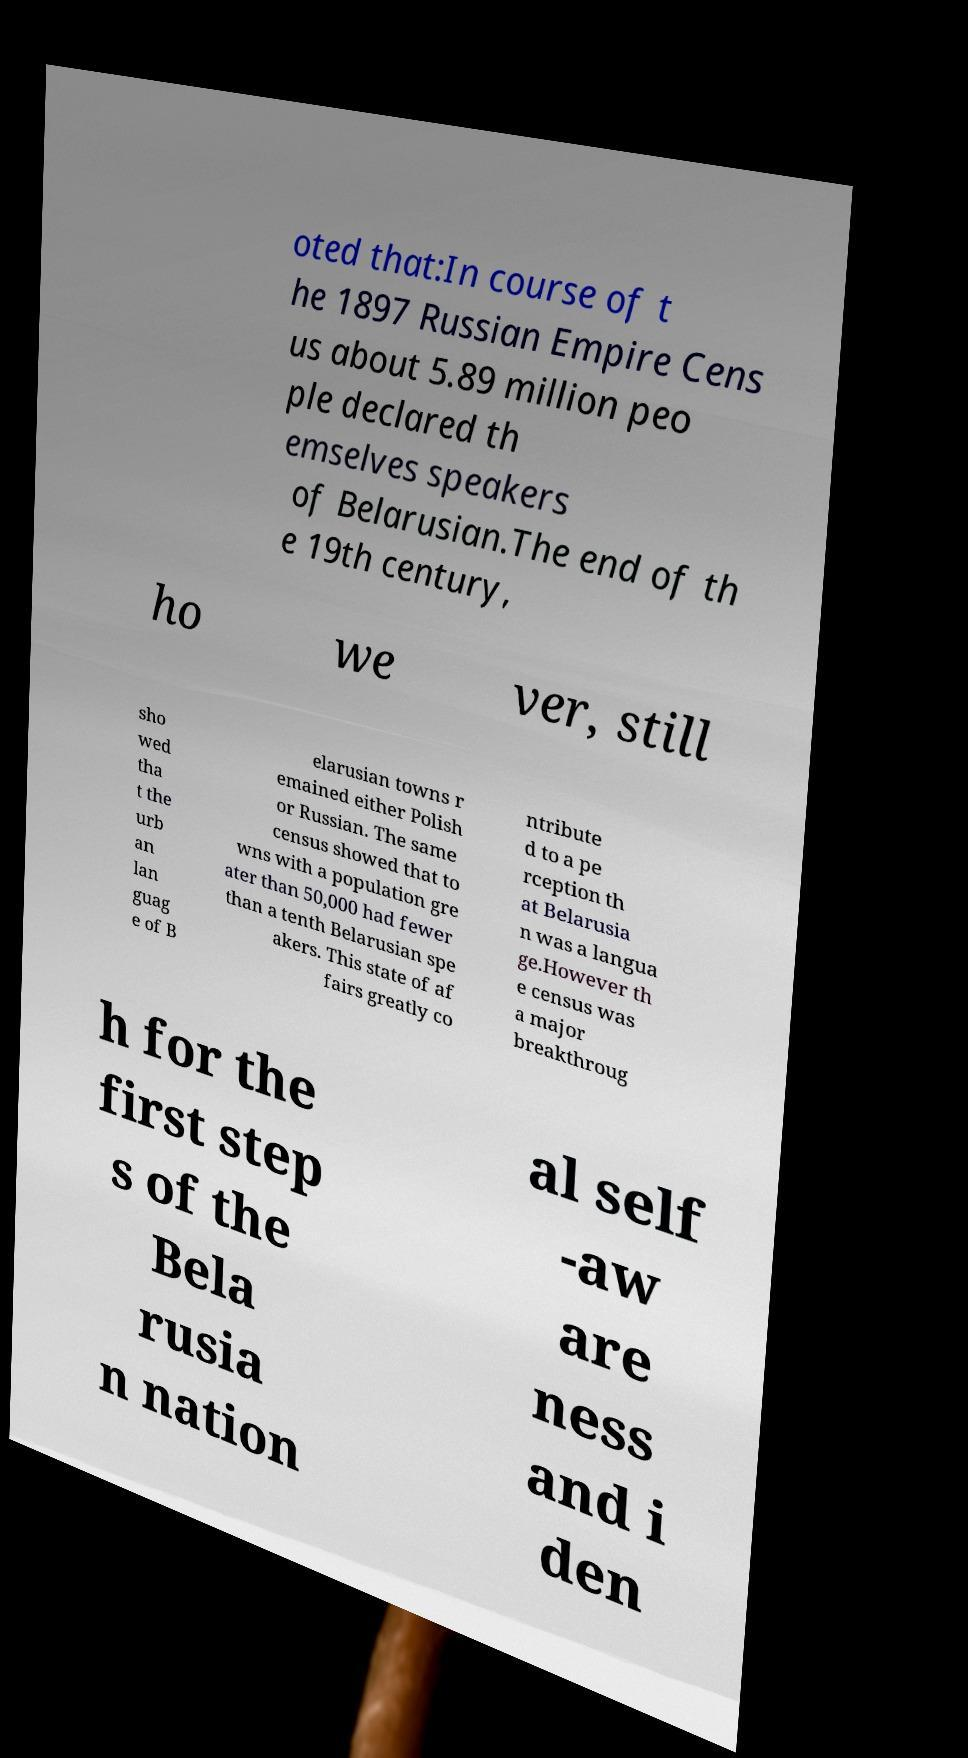Can you read and provide the text displayed in the image?This photo seems to have some interesting text. Can you extract and type it out for me? oted that:In course of t he 1897 Russian Empire Cens us about 5.89 million peo ple declared th emselves speakers of Belarusian.The end of th e 19th century, ho we ver, still sho wed tha t the urb an lan guag e of B elarusian towns r emained either Polish or Russian. The same census showed that to wns with a population gre ater than 50,000 had fewer than a tenth Belarusian spe akers. This state of af fairs greatly co ntribute d to a pe rception th at Belarusia n was a langua ge.However th e census was a major breakthroug h for the first step s of the Bela rusia n nation al self -aw are ness and i den 